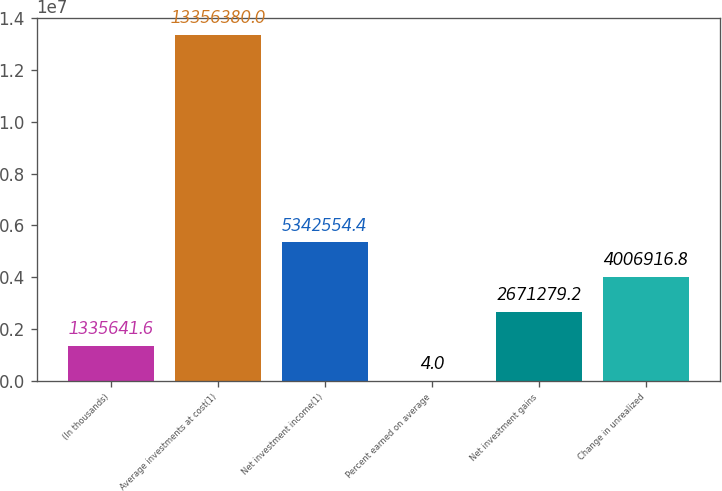<chart> <loc_0><loc_0><loc_500><loc_500><bar_chart><fcel>(In thousands)<fcel>Average investments at cost(1)<fcel>Net investment income(1)<fcel>Percent earned on average<fcel>Net investment gains<fcel>Change in unrealized<nl><fcel>1.33564e+06<fcel>1.33564e+07<fcel>5.34255e+06<fcel>4<fcel>2.67128e+06<fcel>4.00692e+06<nl></chart> 